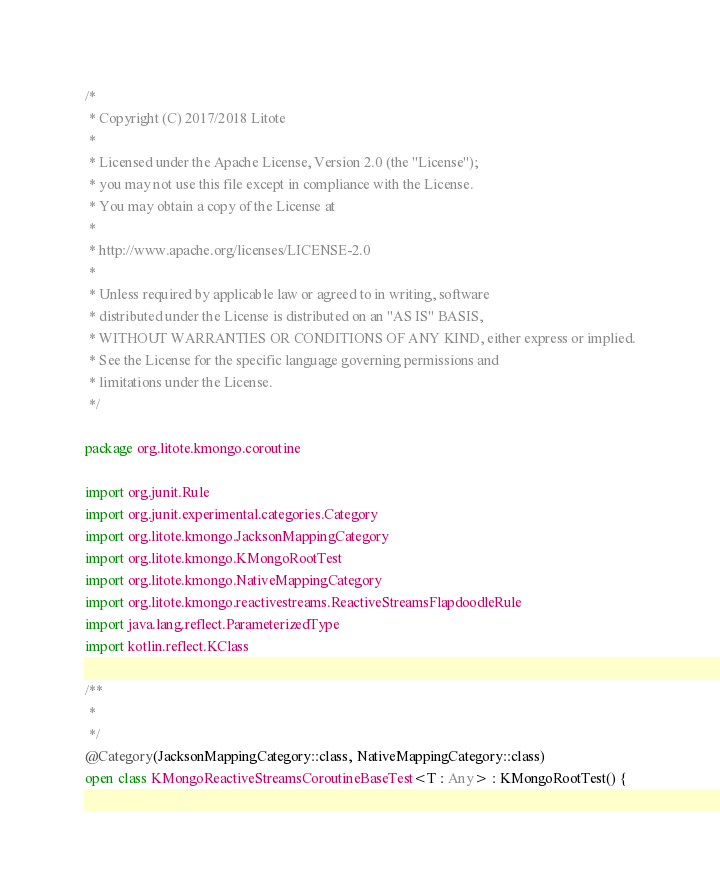<code> <loc_0><loc_0><loc_500><loc_500><_Kotlin_>/*
 * Copyright (C) 2017/2018 Litote
 *
 * Licensed under the Apache License, Version 2.0 (the "License");
 * you may not use this file except in compliance with the License.
 * You may obtain a copy of the License at
 *
 * http://www.apache.org/licenses/LICENSE-2.0
 *
 * Unless required by applicable law or agreed to in writing, software
 * distributed under the License is distributed on an "AS IS" BASIS,
 * WITHOUT WARRANTIES OR CONDITIONS OF ANY KIND, either express or implied.
 * See the License for the specific language governing permissions and
 * limitations under the License.
 */

package org.litote.kmongo.coroutine

import org.junit.Rule
import org.junit.experimental.categories.Category
import org.litote.kmongo.JacksonMappingCategory
import org.litote.kmongo.KMongoRootTest
import org.litote.kmongo.NativeMappingCategory
import org.litote.kmongo.reactivestreams.ReactiveStreamsFlapdoodleRule
import java.lang.reflect.ParameterizedType
import kotlin.reflect.KClass

/**
 *
 */
@Category(JacksonMappingCategory::class, NativeMappingCategory::class)
open class KMongoReactiveStreamsCoroutineBaseTest<T : Any> : KMongoRootTest() {
</code> 